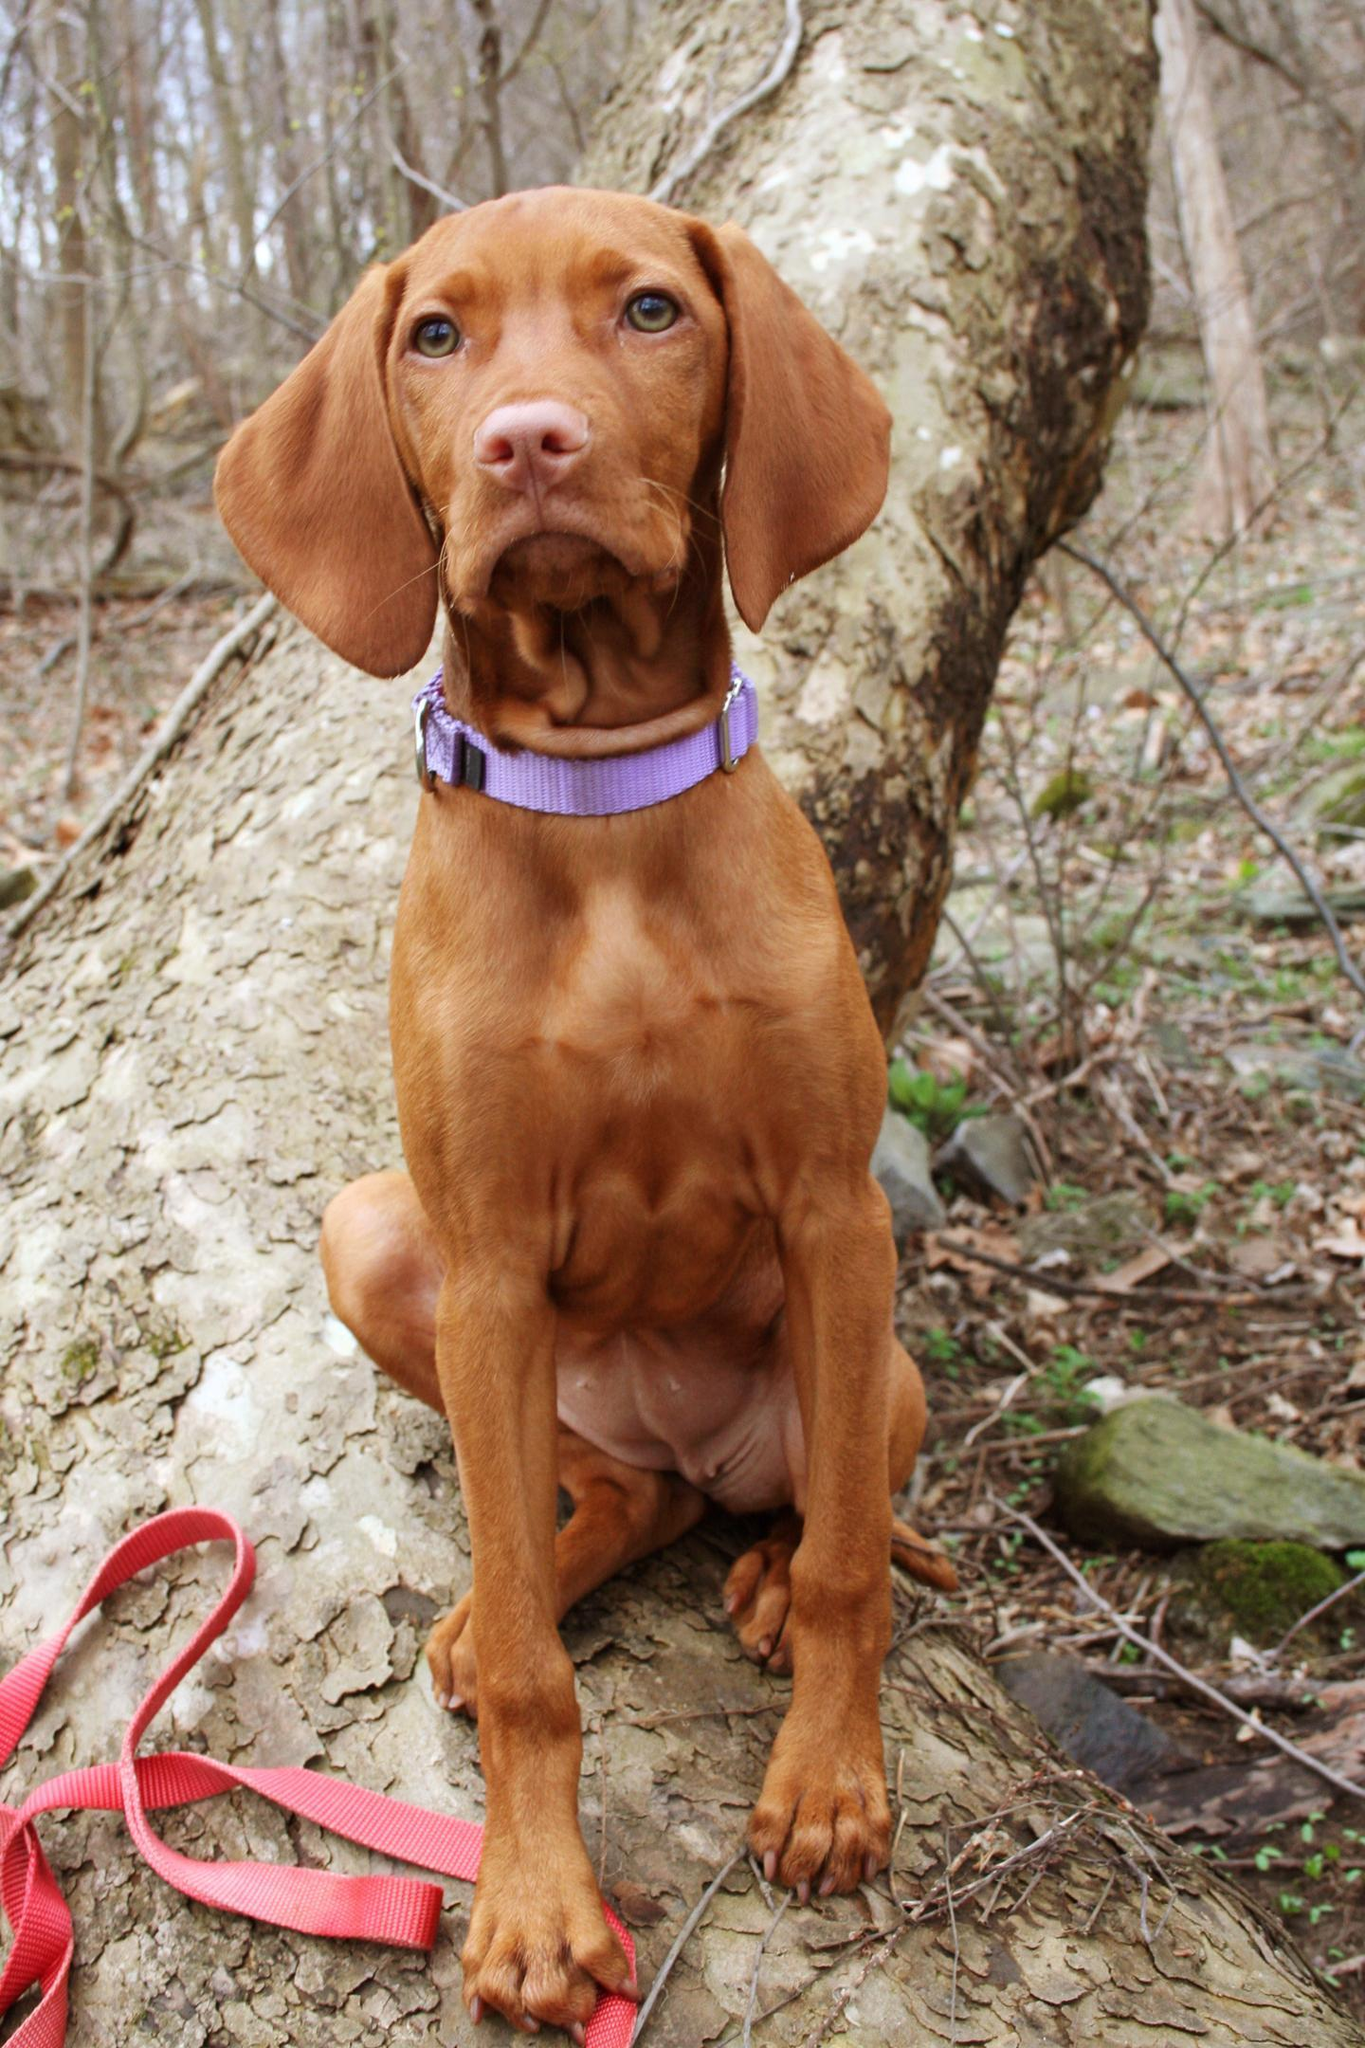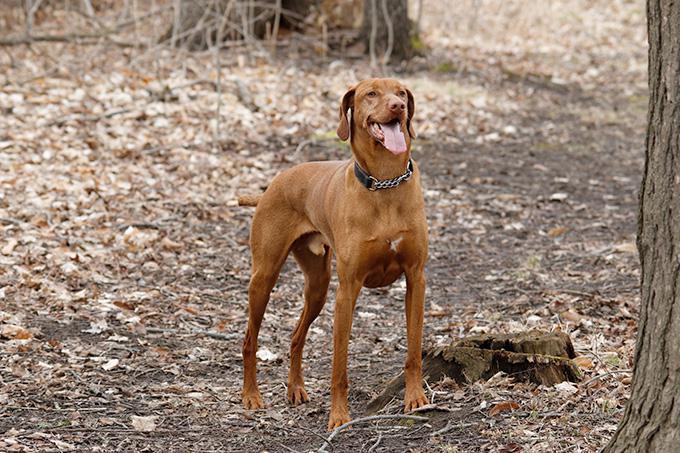The first image is the image on the left, the second image is the image on the right. Examine the images to the left and right. Is the description "Each image shows a single dog that is outside and wearing a collar." accurate? Answer yes or no. Yes. The first image is the image on the left, the second image is the image on the right. Analyze the images presented: Is the assertion "The left image contains one dog sitting upright, and the right image contains one dog standing on all fours." valid? Answer yes or no. Yes. 